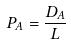<formula> <loc_0><loc_0><loc_500><loc_500>P _ { A } = \frac { D _ { A } } { L }</formula> 